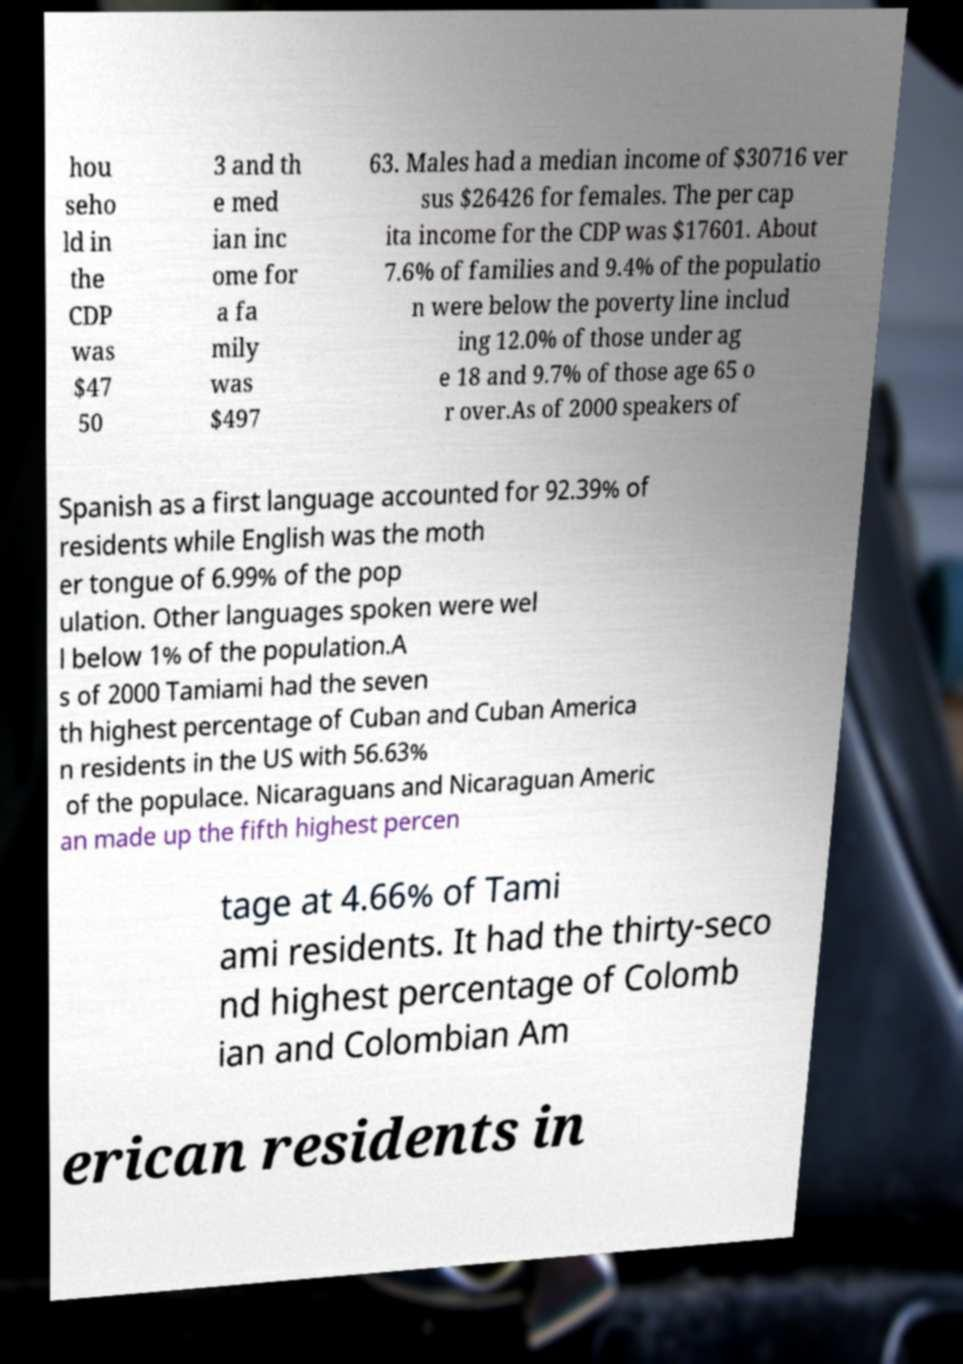For documentation purposes, I need the text within this image transcribed. Could you provide that? hou seho ld in the CDP was $47 50 3 and th e med ian inc ome for a fa mily was $497 63. Males had a median income of $30716 ver sus $26426 for females. The per cap ita income for the CDP was $17601. About 7.6% of families and 9.4% of the populatio n were below the poverty line includ ing 12.0% of those under ag e 18 and 9.7% of those age 65 o r over.As of 2000 speakers of Spanish as a first language accounted for 92.39% of residents while English was the moth er tongue of 6.99% of the pop ulation. Other languages spoken were wel l below 1% of the population.A s of 2000 Tamiami had the seven th highest percentage of Cuban and Cuban America n residents in the US with 56.63% of the populace. Nicaraguans and Nicaraguan Americ an made up the fifth highest percen tage at 4.66% of Tami ami residents. It had the thirty-seco nd highest percentage of Colomb ian and Colombian Am erican residents in 